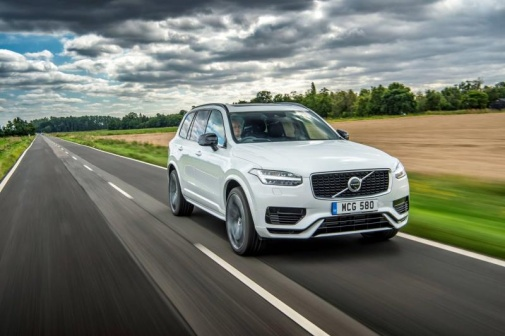What if the image was taken in a futuristic setting? Imagine this SUV traveling on a highway through a futuristic landscape where fields are replaced by smart agriculture grids, with towering vertical farms on either side. The cloudy sky is now part of a weather control system, ensuring optimal conditions for the crops. The road itself is made of a self-repairing material that absorbs rainwater, keeping the surface dry and improving vehicle traction. As the SUV glides along, it communicates with other vehicles and the road infrastructure to optimize traffic flow and enhance safety. The vehicle's AI system narrates the history of the region and explains the technology that's shaping this advanced civilization, making the drive both a journey and an education through this high-tech yet environmentally harmonious world. 